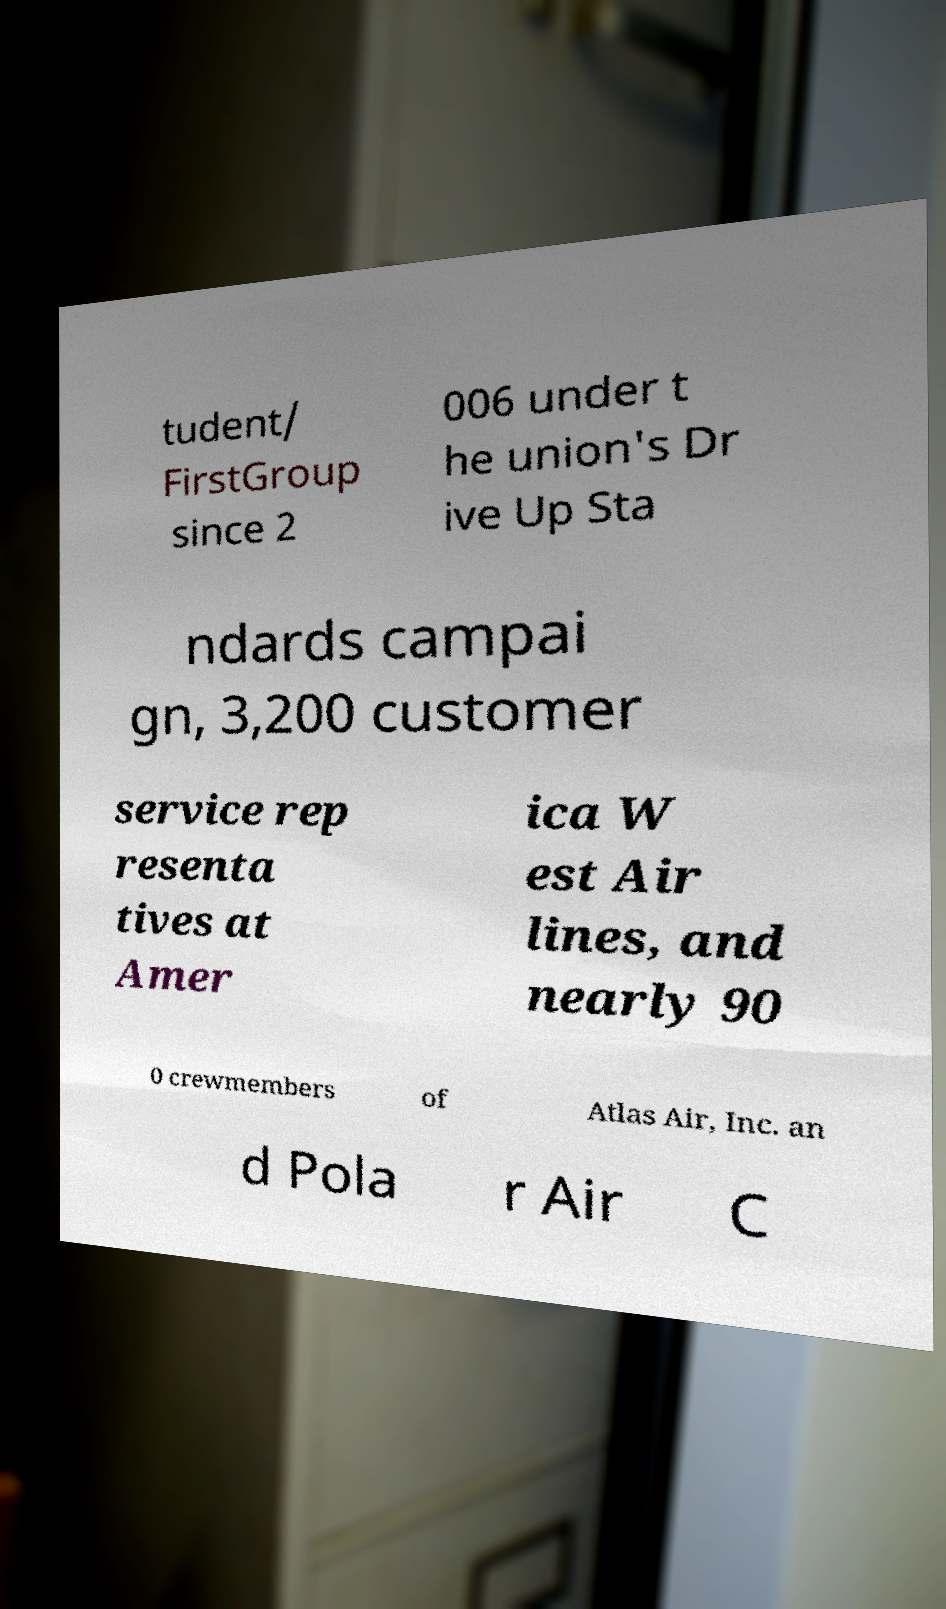Please identify and transcribe the text found in this image. tudent/ FirstGroup since 2 006 under t he union's Dr ive Up Sta ndards campai gn, 3,200 customer service rep resenta tives at Amer ica W est Air lines, and nearly 90 0 crewmembers of Atlas Air, Inc. an d Pola r Air C 